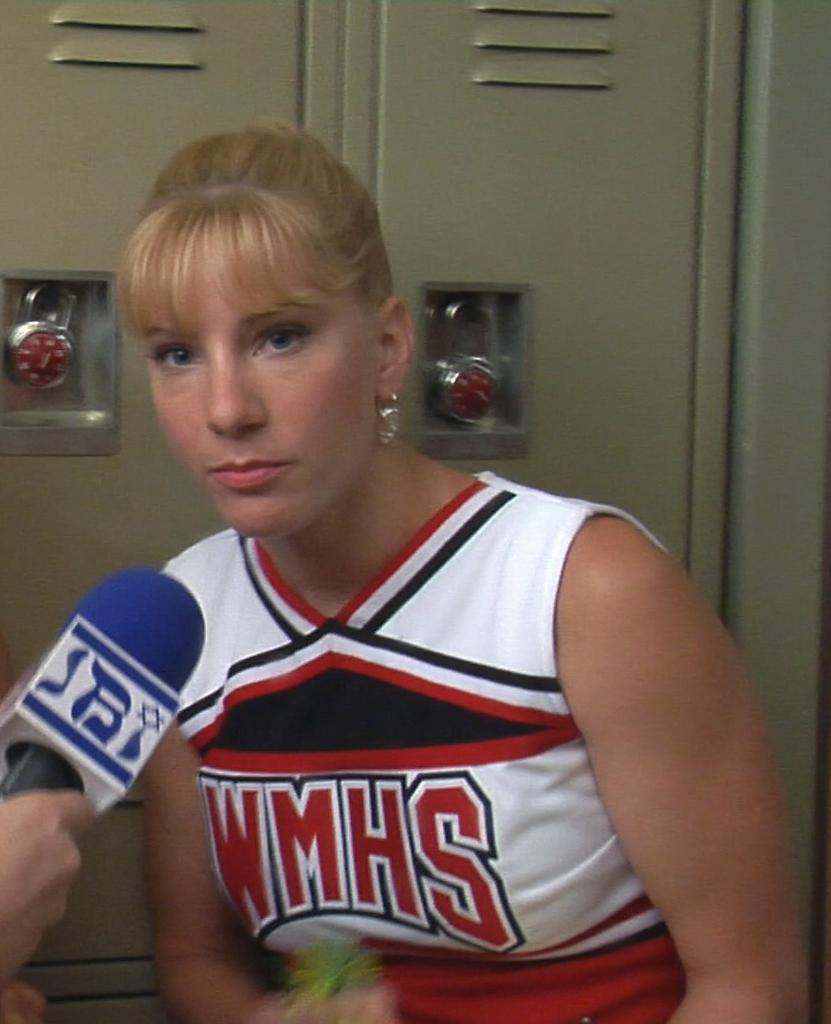<image>
Relay a brief, clear account of the picture shown. A girl is in a uniform with WMHS on the front. 